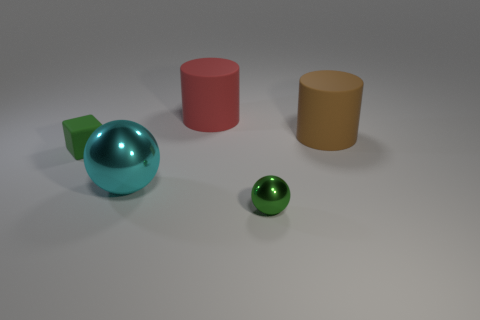Add 4 rubber cubes. How many objects exist? 9 Subtract all cylinders. How many objects are left? 3 Subtract all red cubes. How many yellow cylinders are left? 0 Subtract all large brown cylinders. Subtract all large objects. How many objects are left? 1 Add 2 big red cylinders. How many big red cylinders are left? 3 Add 3 small brown metal balls. How many small brown metal balls exist? 3 Subtract 0 yellow cubes. How many objects are left? 5 Subtract 1 cylinders. How many cylinders are left? 1 Subtract all yellow spheres. Subtract all yellow cylinders. How many spheres are left? 2 